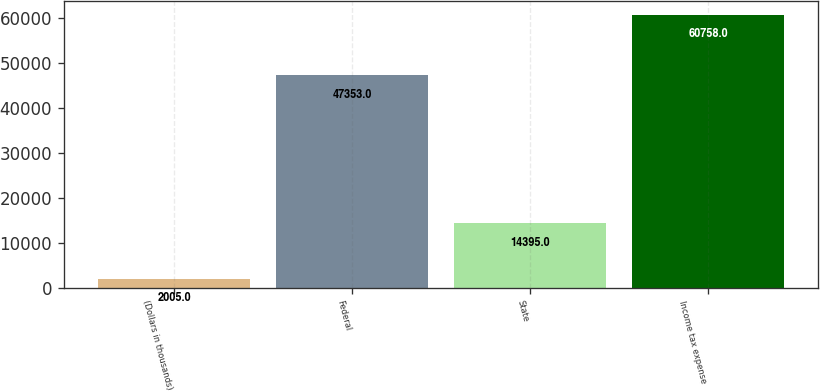Convert chart. <chart><loc_0><loc_0><loc_500><loc_500><bar_chart><fcel>(Dollars in thousands)<fcel>Federal<fcel>State<fcel>Income tax expense<nl><fcel>2005<fcel>47353<fcel>14395<fcel>60758<nl></chart> 